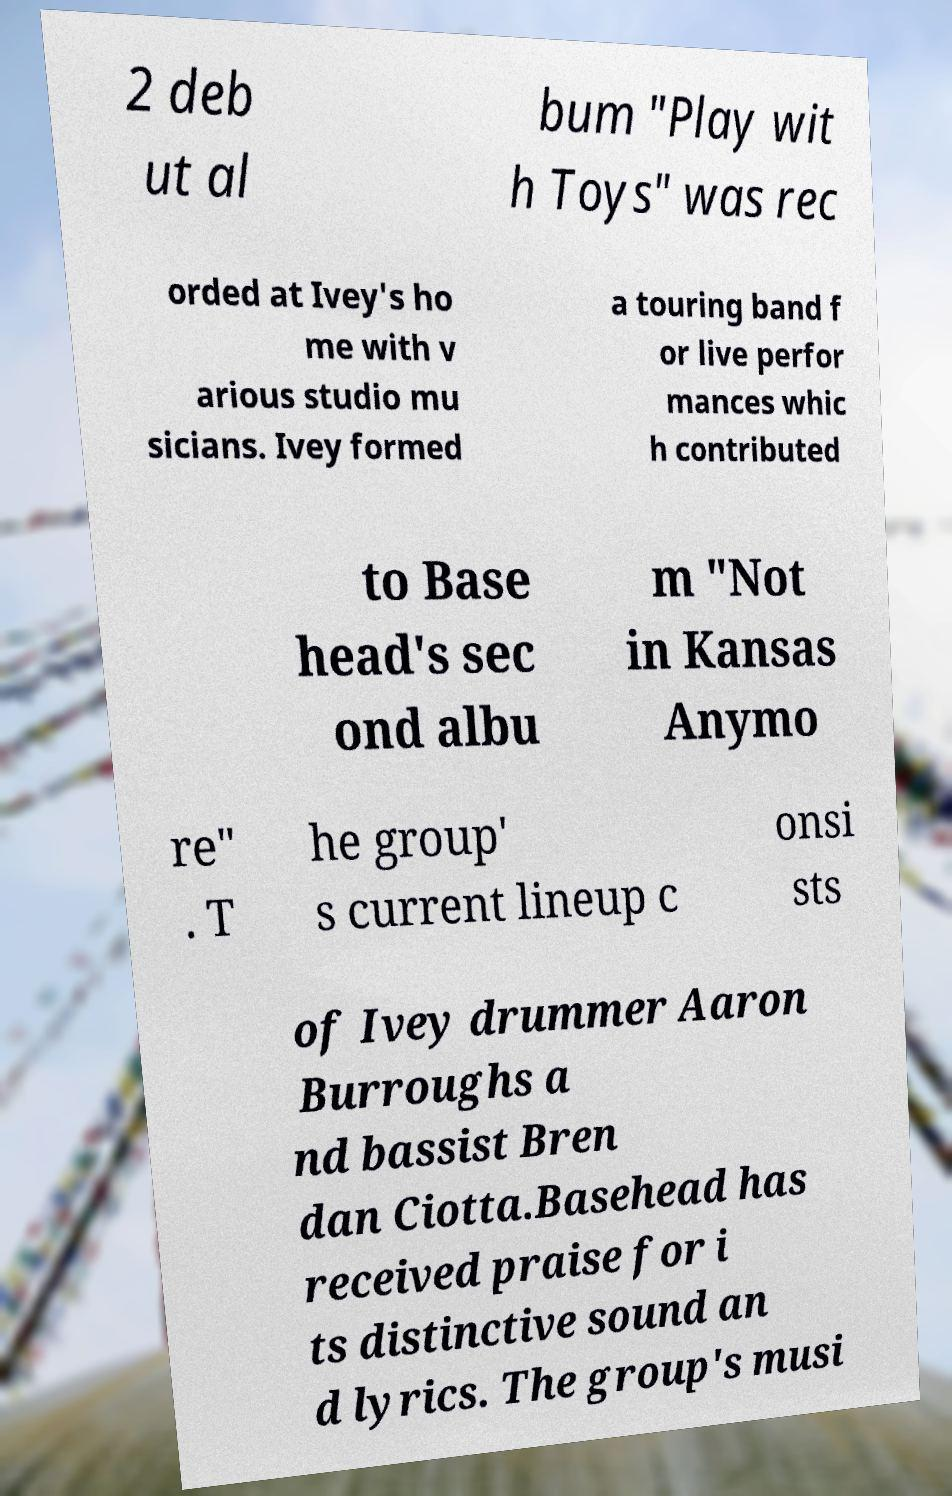Can you read and provide the text displayed in the image?This photo seems to have some interesting text. Can you extract and type it out for me? 2 deb ut al bum "Play wit h Toys" was rec orded at Ivey's ho me with v arious studio mu sicians. Ivey formed a touring band f or live perfor mances whic h contributed to Base head's sec ond albu m "Not in Kansas Anymo re" . T he group' s current lineup c onsi sts of Ivey drummer Aaron Burroughs a nd bassist Bren dan Ciotta.Basehead has received praise for i ts distinctive sound an d lyrics. The group's musi 